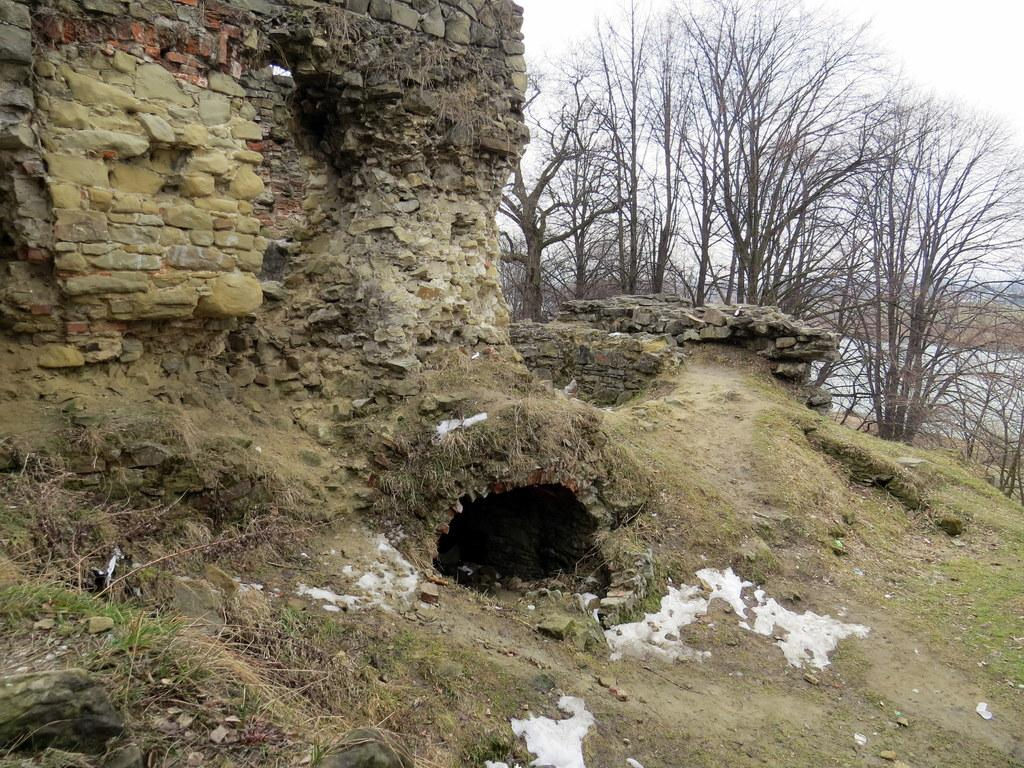What type of natural elements can be seen in the foreground of the image? There is grass, stones, and soil in the foreground of the image. What man-made structure is located in the middle of the image? There is a stone construction in the middle of the image. What type of vegetation is visible in the background of the image? There are trees in the background of the image. What part of the natural environment is visible in the background of the image? The sky is visible in the background of the image. What type of popcorn is being served in the church depicted in the image? There is no church or popcorn present in the image. 